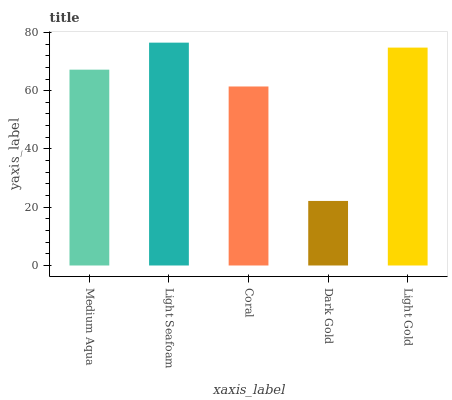Is Dark Gold the minimum?
Answer yes or no. Yes. Is Light Seafoam the maximum?
Answer yes or no. Yes. Is Coral the minimum?
Answer yes or no. No. Is Coral the maximum?
Answer yes or no. No. Is Light Seafoam greater than Coral?
Answer yes or no. Yes. Is Coral less than Light Seafoam?
Answer yes or no. Yes. Is Coral greater than Light Seafoam?
Answer yes or no. No. Is Light Seafoam less than Coral?
Answer yes or no. No. Is Medium Aqua the high median?
Answer yes or no. Yes. Is Medium Aqua the low median?
Answer yes or no. Yes. Is Light Seafoam the high median?
Answer yes or no. No. Is Coral the low median?
Answer yes or no. No. 